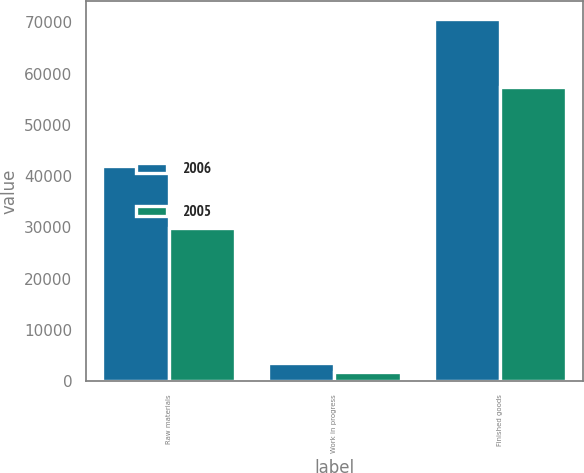Convert chart. <chart><loc_0><loc_0><loc_500><loc_500><stacked_bar_chart><ecel><fcel>Raw materials<fcel>Work in progress<fcel>Finished goods<nl><fcel>2006<fcel>41979<fcel>3520<fcel>70695<nl><fcel>2005<fcel>29857<fcel>1820<fcel>57430<nl></chart> 